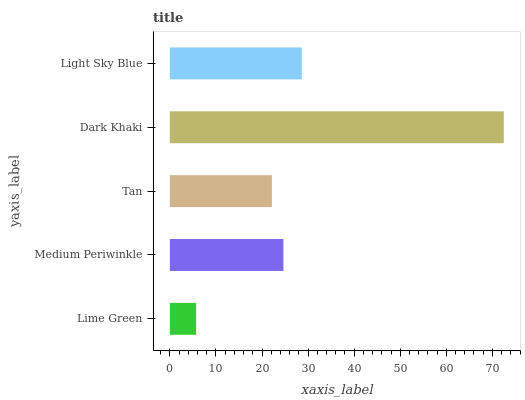Is Lime Green the minimum?
Answer yes or no. Yes. Is Dark Khaki the maximum?
Answer yes or no. Yes. Is Medium Periwinkle the minimum?
Answer yes or no. No. Is Medium Periwinkle the maximum?
Answer yes or no. No. Is Medium Periwinkle greater than Lime Green?
Answer yes or no. Yes. Is Lime Green less than Medium Periwinkle?
Answer yes or no. Yes. Is Lime Green greater than Medium Periwinkle?
Answer yes or no. No. Is Medium Periwinkle less than Lime Green?
Answer yes or no. No. Is Medium Periwinkle the high median?
Answer yes or no. Yes. Is Medium Periwinkle the low median?
Answer yes or no. Yes. Is Light Sky Blue the high median?
Answer yes or no. No. Is Tan the low median?
Answer yes or no. No. 